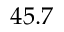<formula> <loc_0><loc_0><loc_500><loc_500>4 5 . 7</formula> 